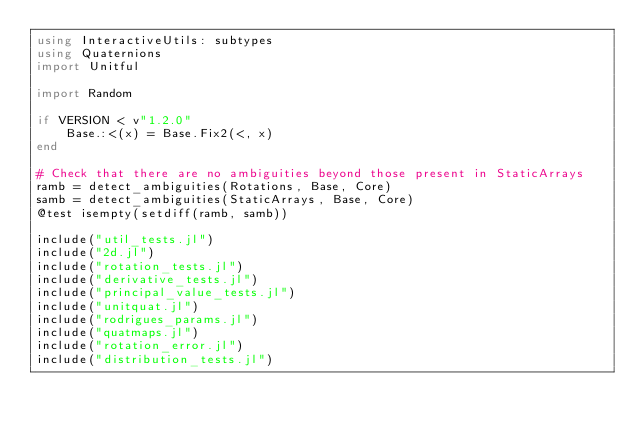Convert code to text. <code><loc_0><loc_0><loc_500><loc_500><_Julia_>using InteractiveUtils: subtypes
using Quaternions
import Unitful

import Random

if VERSION < v"1.2.0"
    Base.:<(x) = Base.Fix2(<, x)
end

# Check that there are no ambiguities beyond those present in StaticArrays
ramb = detect_ambiguities(Rotations, Base, Core)
samb = detect_ambiguities(StaticArrays, Base, Core)
@test isempty(setdiff(ramb, samb))

include("util_tests.jl")
include("2d.jl")
include("rotation_tests.jl")
include("derivative_tests.jl")
include("principal_value_tests.jl")
include("unitquat.jl")
include("rodrigues_params.jl")
include("quatmaps.jl")
include("rotation_error.jl")
include("distribution_tests.jl")</code> 